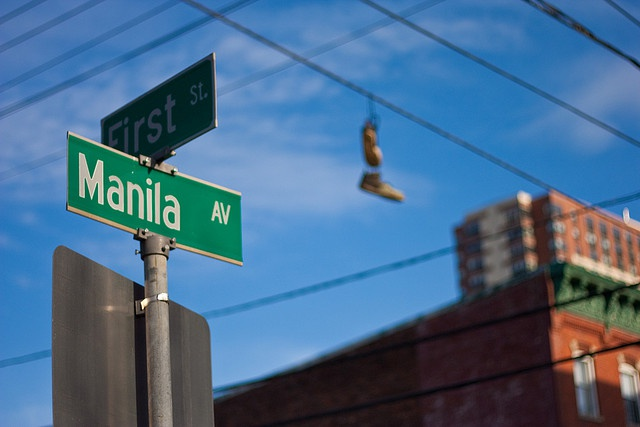Describe the objects in this image and their specific colors. I can see various objects in this image with different colors. 